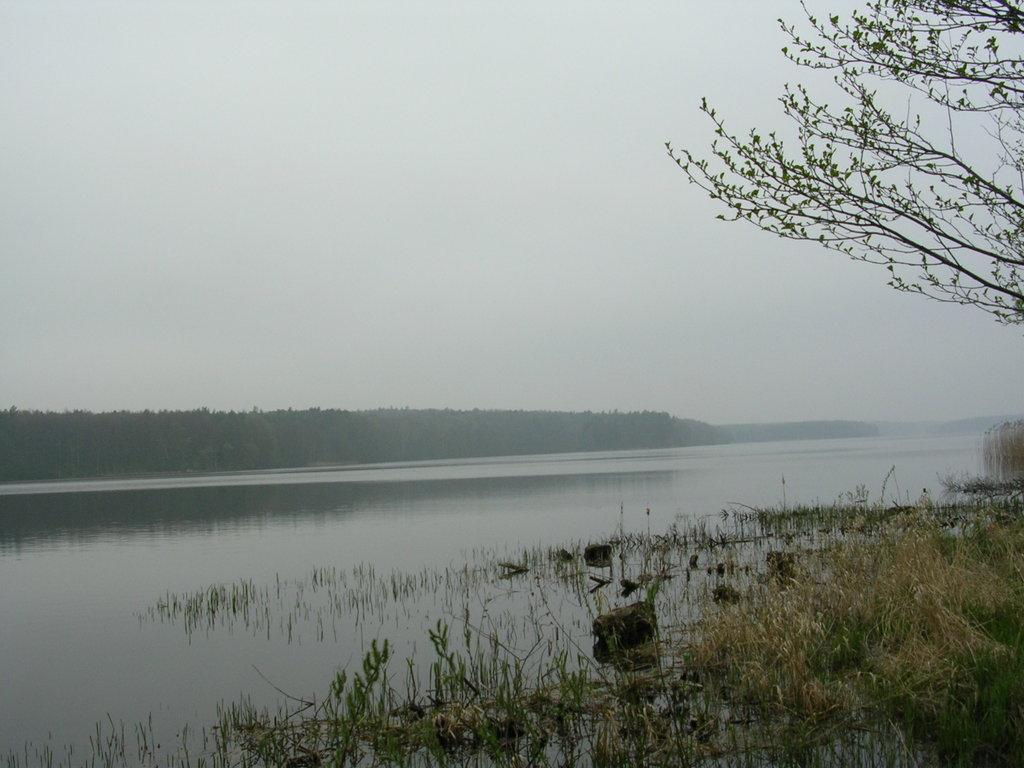What type of vegetation is present in the image? There is grass in the image. What natural feature can be seen in the image? There is a water surface in the image. What can be seen in the background of the image? There are trees in the background of the image. Can you describe the condition of the tree on the right side of the image? There is a dry tree on the right side of the image. What type of watch can be seen on the water surface in the image? There is no watch present on the water surface in the image. 